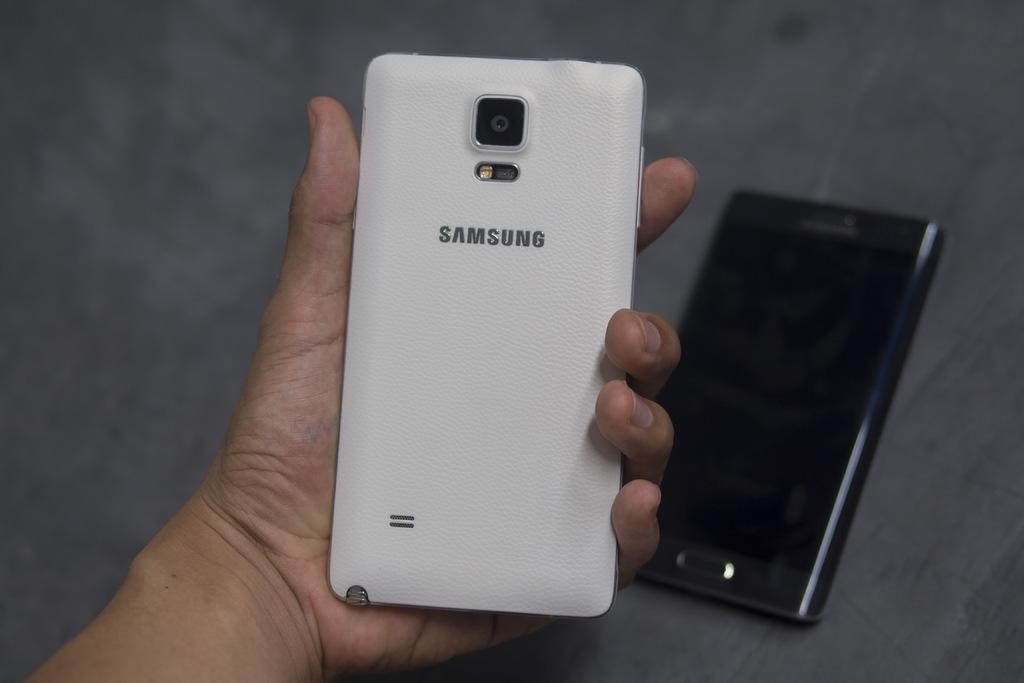What brand of phone is this?
Offer a terse response. Samsung. 